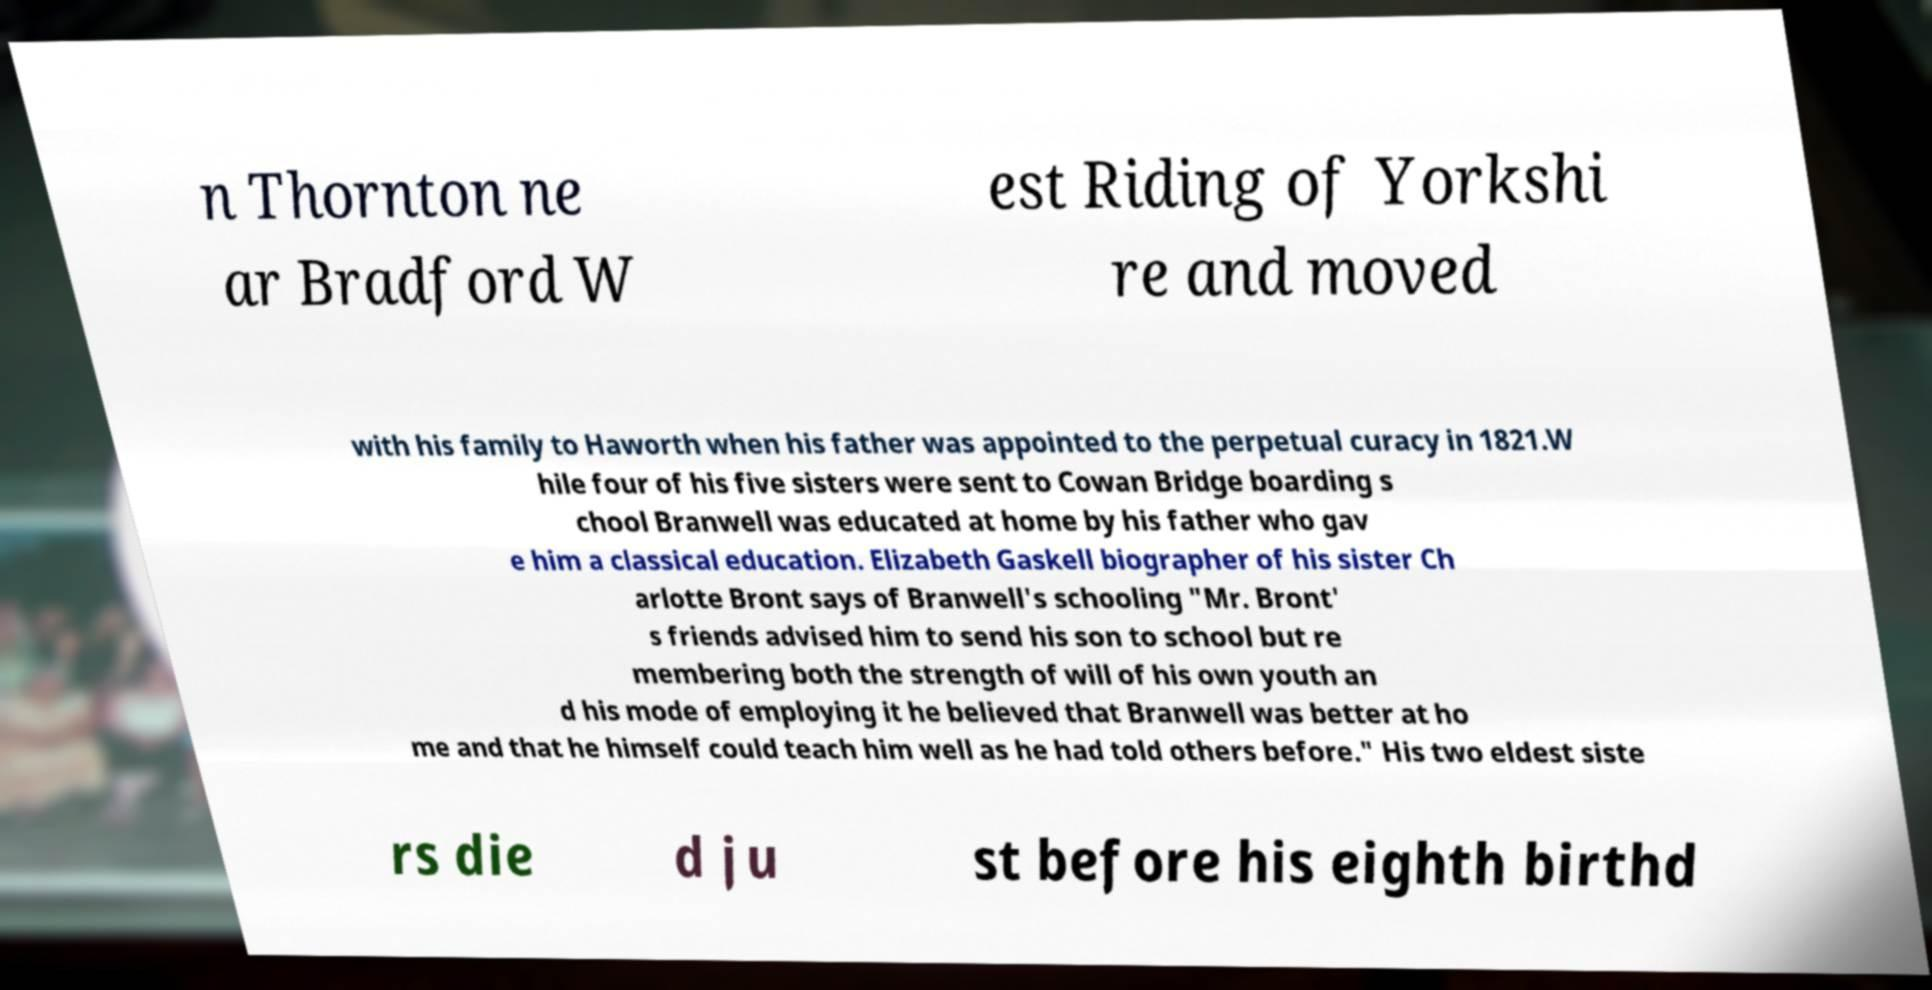Could you extract and type out the text from this image? n Thornton ne ar Bradford W est Riding of Yorkshi re and moved with his family to Haworth when his father was appointed to the perpetual curacy in 1821.W hile four of his five sisters were sent to Cowan Bridge boarding s chool Branwell was educated at home by his father who gav e him a classical education. Elizabeth Gaskell biographer of his sister Ch arlotte Bront says of Branwell's schooling "Mr. Bront' s friends advised him to send his son to school but re membering both the strength of will of his own youth an d his mode of employing it he believed that Branwell was better at ho me and that he himself could teach him well as he had told others before." His two eldest siste rs die d ju st before his eighth birthd 